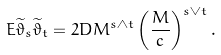<formula> <loc_0><loc_0><loc_500><loc_500>E \widetilde { \vartheta } _ { s } \widetilde { \vartheta } _ { t } = 2 D M ^ { s \wedge t } \left ( \frac { M } { c } \right ) ^ { s \vee t } .</formula> 